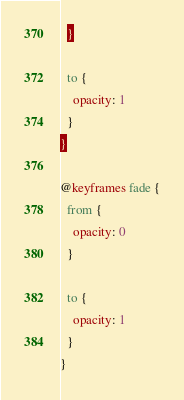Convert code to text. <code><loc_0><loc_0><loc_500><loc_500><_CSS_>  }

  to {
    opacity: 1
  }
}

@keyframes fade {
  from {
    opacity: 0
  }

  to {
    opacity: 1
  }
}</code> 